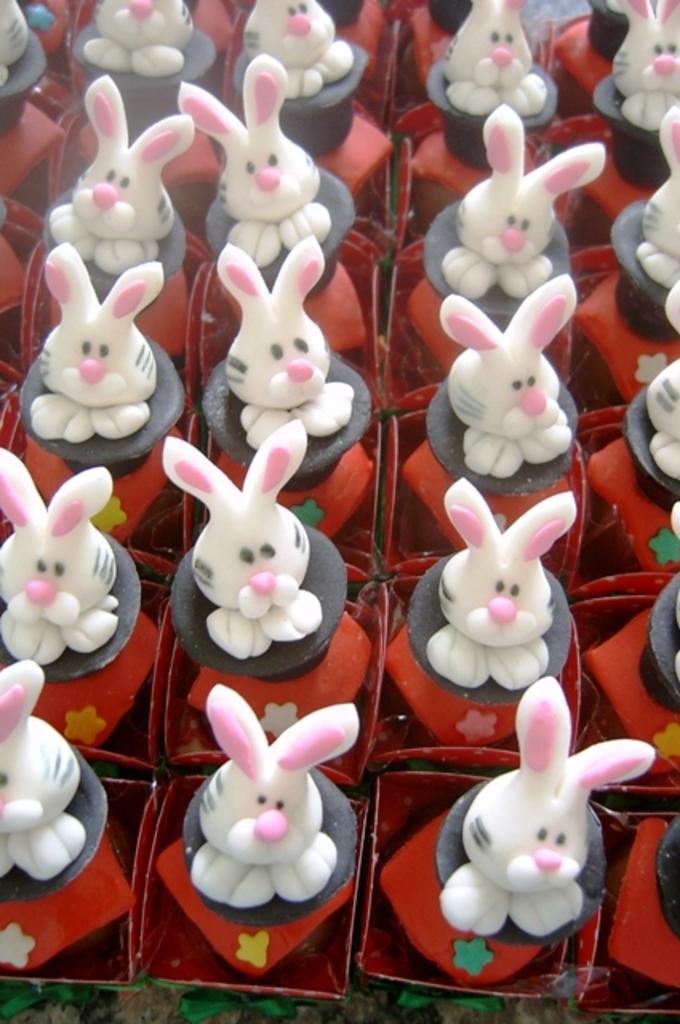Could you give a brief overview of what you see in this image? In this image we can see some bunny toys, and the borders are white in color. 